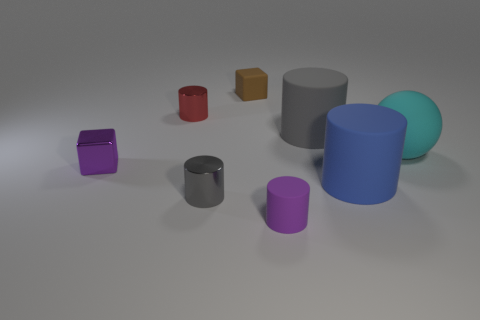Subtract all tiny red shiny cylinders. How many cylinders are left? 4 Add 2 matte things. How many objects exist? 10 Subtract all purple cylinders. How many cylinders are left? 4 Subtract 3 cylinders. How many cylinders are left? 2 Subtract all blocks. How many objects are left? 6 Subtract all yellow spheres. Subtract all yellow blocks. How many spheres are left? 1 Subtract all brown cubes. How many gray cylinders are left? 2 Subtract all purple blocks. Subtract all small purple matte things. How many objects are left? 6 Add 8 gray matte objects. How many gray matte objects are left? 9 Add 7 big gray cylinders. How many big gray cylinders exist? 8 